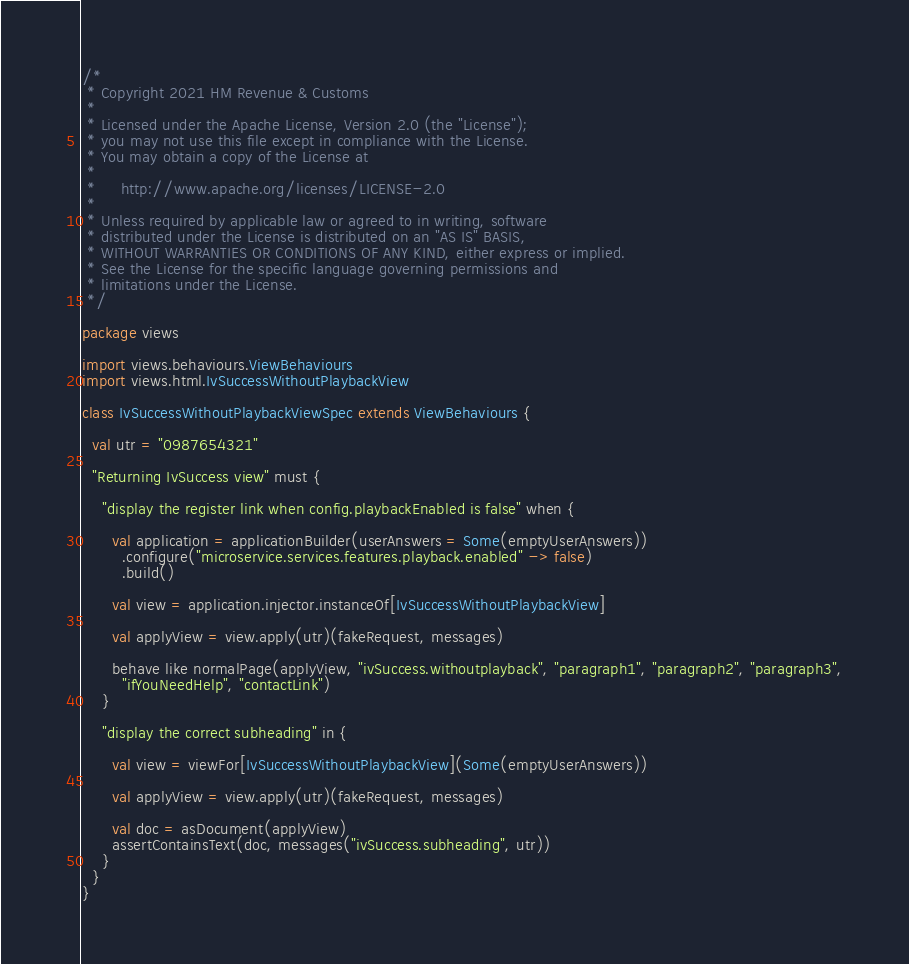<code> <loc_0><loc_0><loc_500><loc_500><_Scala_>/*
 * Copyright 2021 HM Revenue & Customs
 *
 * Licensed under the Apache License, Version 2.0 (the "License");
 * you may not use this file except in compliance with the License.
 * You may obtain a copy of the License at
 *
 *     http://www.apache.org/licenses/LICENSE-2.0
 *
 * Unless required by applicable law or agreed to in writing, software
 * distributed under the License is distributed on an "AS IS" BASIS,
 * WITHOUT WARRANTIES OR CONDITIONS OF ANY KIND, either express or implied.
 * See the License for the specific language governing permissions and
 * limitations under the License.
 */

package views

import views.behaviours.ViewBehaviours
import views.html.IvSuccessWithoutPlaybackView

class IvSuccessWithoutPlaybackViewSpec extends ViewBehaviours {

  val utr = "0987654321"

  "Returning IvSuccess view" must {

    "display the register link when config.playbackEnabled is false" when {

      val application = applicationBuilder(userAnswers = Some(emptyUserAnswers))
        .configure("microservice.services.features.playback.enabled" -> false)
        .build()

      val view = application.injector.instanceOf[IvSuccessWithoutPlaybackView]

      val applyView = view.apply(utr)(fakeRequest, messages)

      behave like normalPage(applyView, "ivSuccess.withoutplayback", "paragraph1", "paragraph2", "paragraph3",
        "ifYouNeedHelp", "contactLink")
    }

    "display the correct subheading" in {

      val view = viewFor[IvSuccessWithoutPlaybackView](Some(emptyUserAnswers))

      val applyView = view.apply(utr)(fakeRequest, messages)

      val doc = asDocument(applyView)
      assertContainsText(doc, messages("ivSuccess.subheading", utr))
    }
  }
}
</code> 